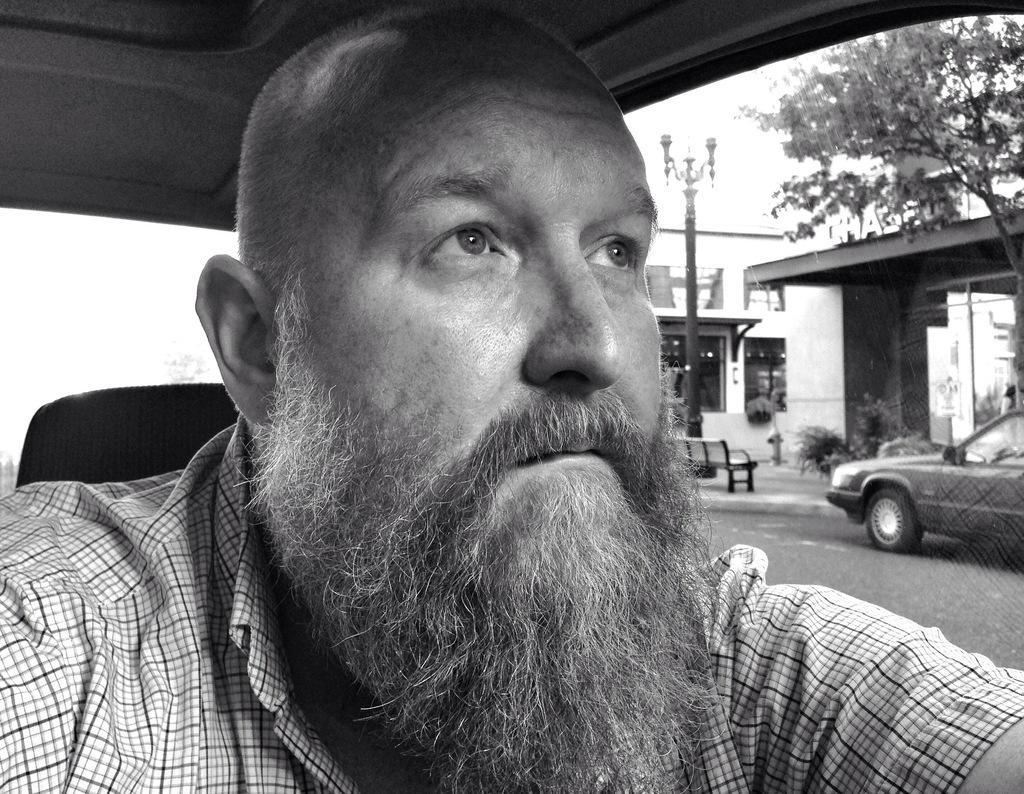Can you describe this image briefly? As we can see the image is a black and white picture in which there is a man who is in front and behind him there is a street lamp pole and behind the pole there is a building and in front of the building there is a tree over here and there is a car which is standing on the road. 